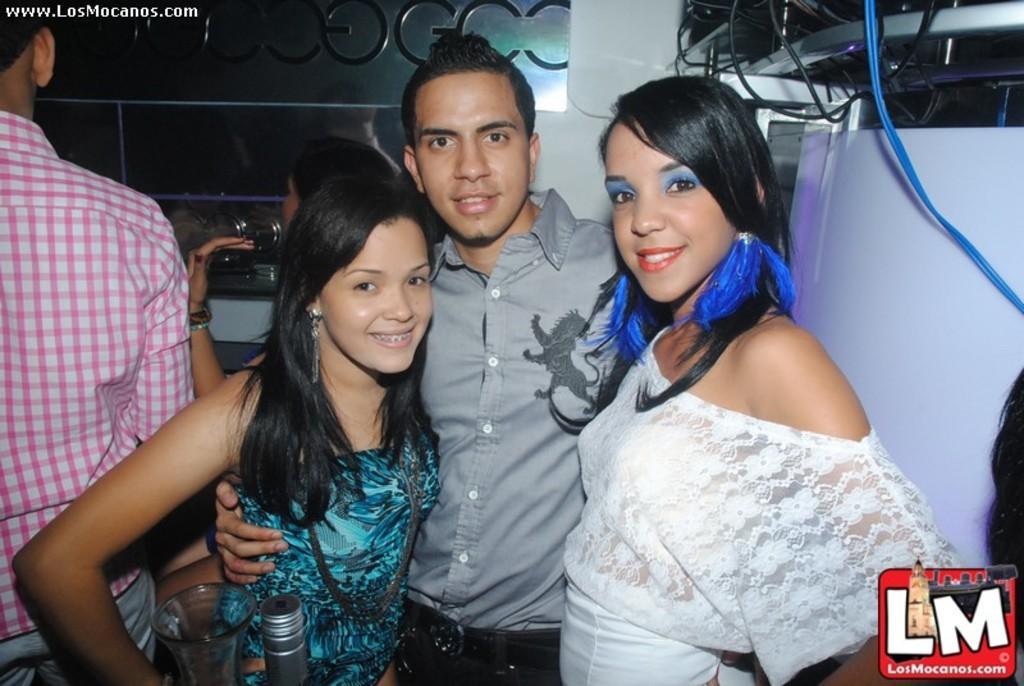Please provide a concise description of this image. This picture shows couple of people standing and we see a bottle and a glass and we see smile on their faces and we see a metal fence. 